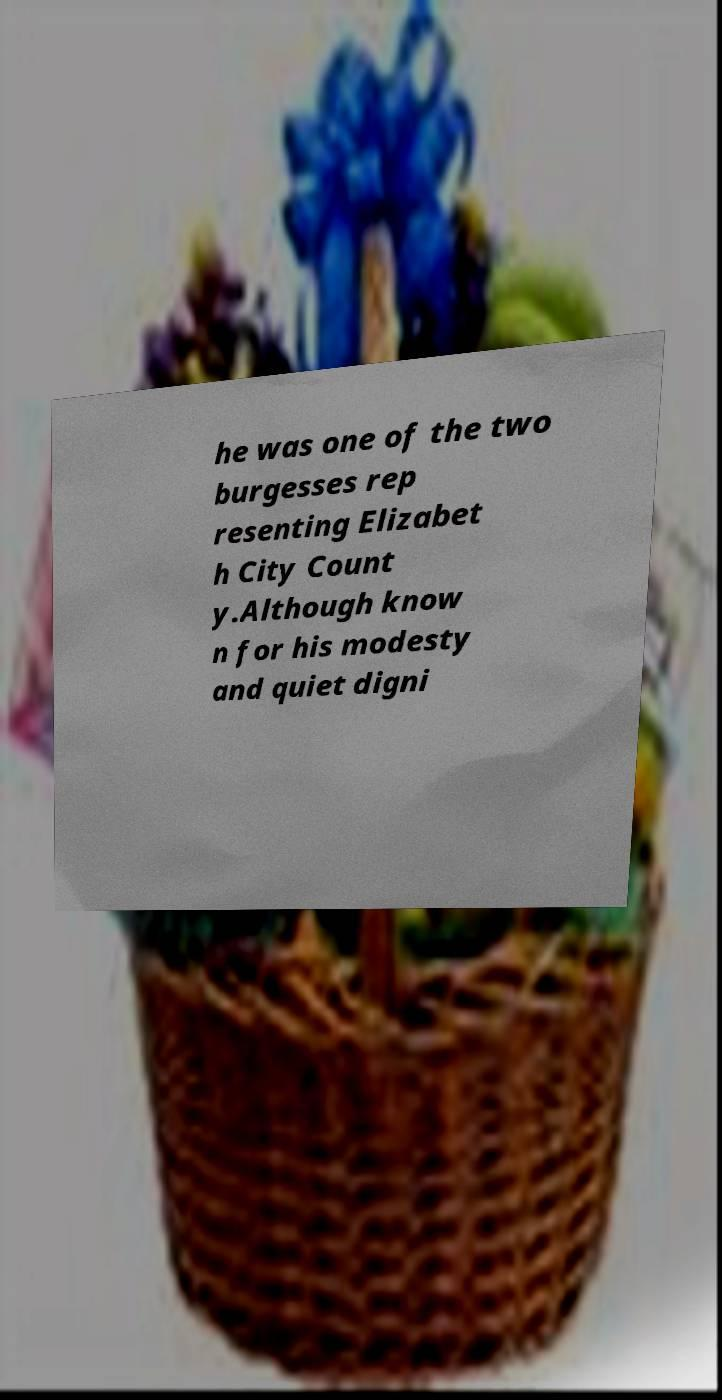Can you read and provide the text displayed in the image?This photo seems to have some interesting text. Can you extract and type it out for me? he was one of the two burgesses rep resenting Elizabet h City Count y.Although know n for his modesty and quiet digni 